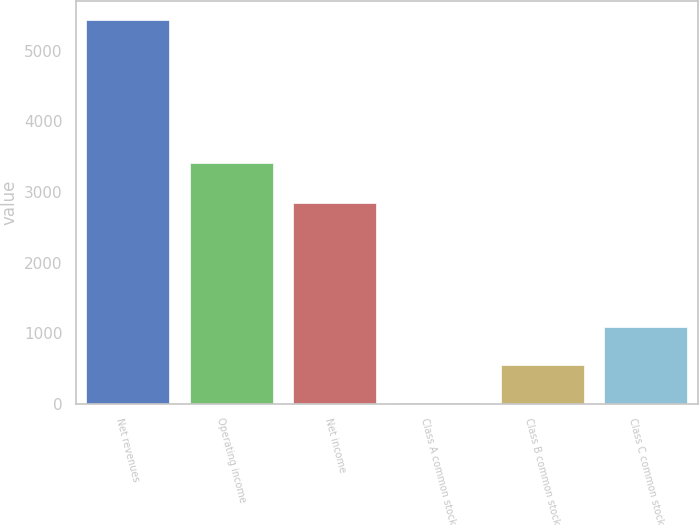Convert chart to OTSL. <chart><loc_0><loc_0><loc_500><loc_500><bar_chart><fcel>Net revenues<fcel>Operating income<fcel>Net income<fcel>Class A common stock<fcel>Class B common stock<fcel>Class C common stock<nl><fcel>5434<fcel>3406<fcel>2845<fcel>1.24<fcel>544.52<fcel>1087.8<nl></chart> 